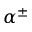<formula> <loc_0><loc_0><loc_500><loc_500>\alpha ^ { \pm }</formula> 